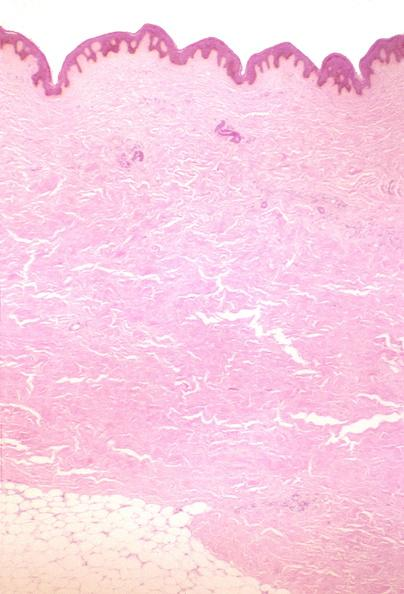where is this?
Answer the question using a single word or phrase. Skin 